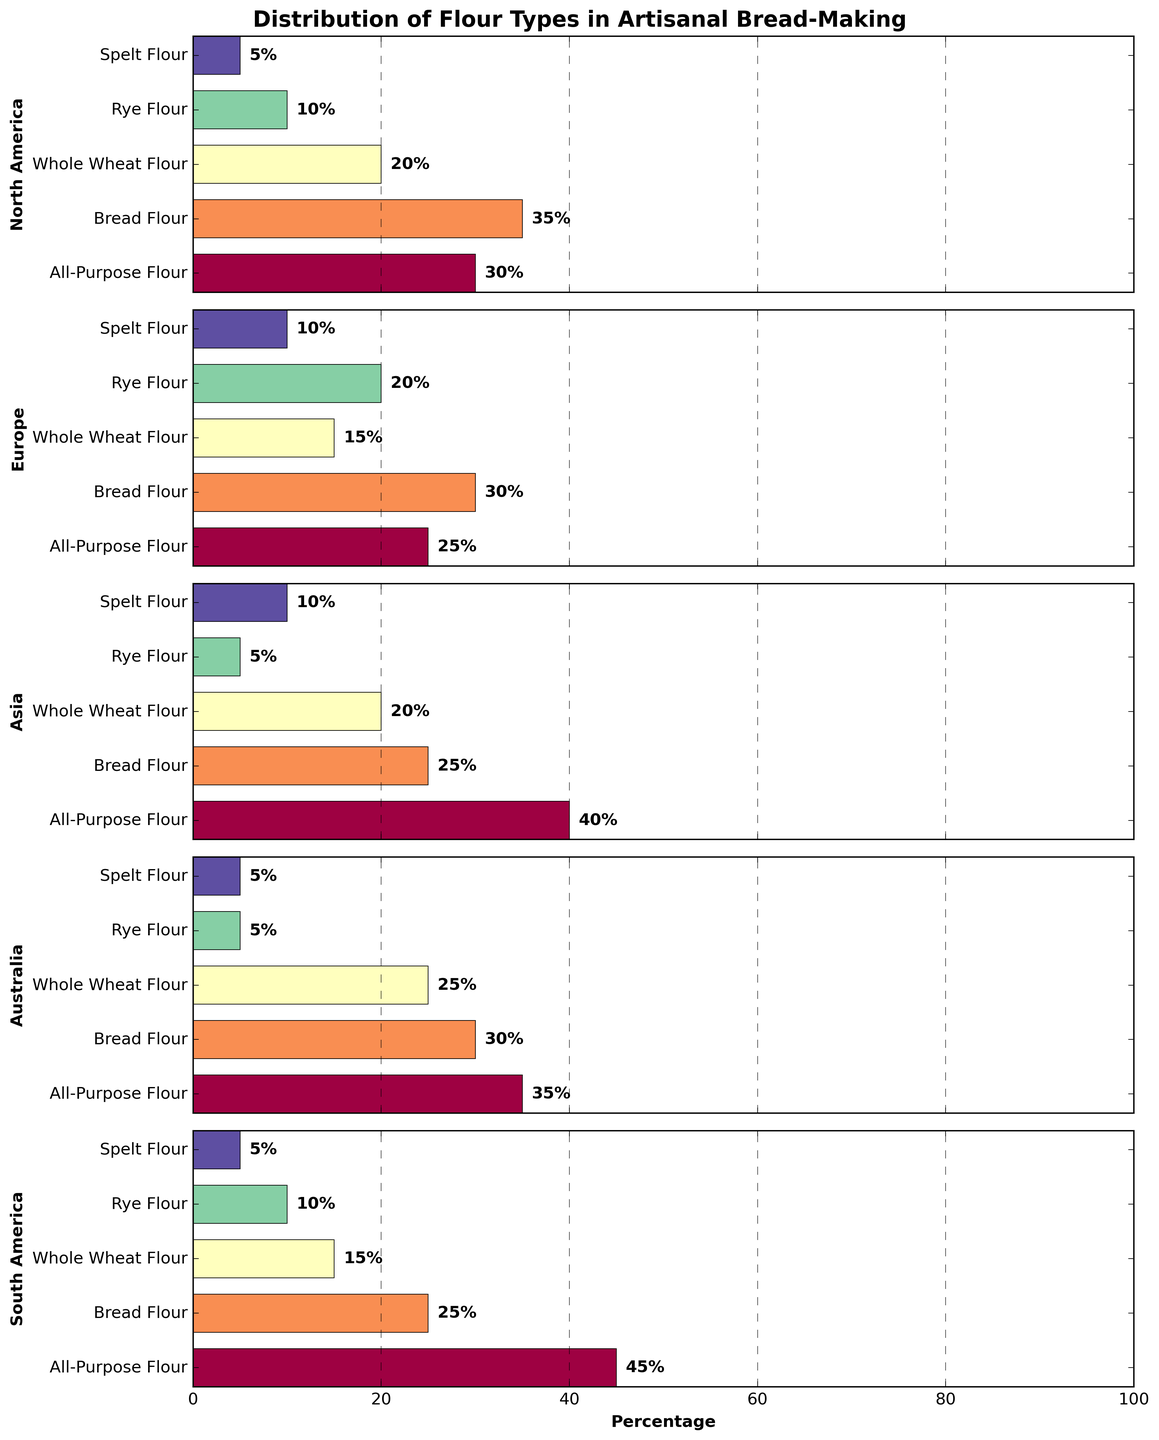What's the most common type of flour used in North America? By looking at the North America subplot, the flour type with the highest percentage bar is Bread Flour at 35%.
Answer: Bread Flour Which region uses the least amount of Whole Wheat Flour? Comparing the length of the bars associated with Whole Wheat Flour across all regions, South America and Europe both use the least amount, each having 15%.
Answer: Europe and South America Between Asia and Australia, which region has a higher percentage of Spelt Flour used? Observe the Spelt Flour bar for both regions and compare their lengths. Both regions use 10% of Spelt Flour.
Answer: Equal What is the sum of Rye Flour percentages for North America and South America? North America uses 10% Rye Flour and South America also uses 10%. Adding these together: 10% + 10% = 20%.
Answer: 20% In which region is the diversity of flour types the most even (least disparity in percentages)? By evaluating how close the percentage values are to each other within each region, Europe appears to have the most even distribution with values ranging from 10% to 30%.
Answer: Europe Which flour type is used the least in Australia and what percentage? The shortest bars in the Australia subplot are for Rye Flour and Spelt Flour, each at 5%.
Answer: Rye Flour and Spelt Flour Among all the regions, which one uses the least amount of Bread Flour? Comparing the Bread Flour percentages across all regions, Asia has the lowest percentage at 25%.
Answer: Asia How does the use of All-Purpose Flour compare between North America and South America? North America uses 30% All-Purpose Flour while South America uses 45%. South America uses a higher percentage.
Answer: South America uses more What's the total percentage of artisanal bread flour type usage in Europe? Adding the percentages for Europe: 25% (All-Purpose) + 30% (Bread) + 15% (Whole Wheat) + 20% (Rye) + 10% (Spelt) = 100%.
Answer: 100% Which region uses the highest percentage of All-Purpose Flour? Observing the All-Purpose Flour bar across all regions, South America uses the highest percentage at 45%.
Answer: South America 